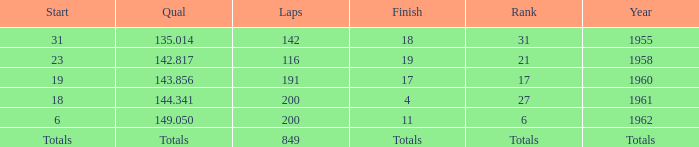What is the year with 116 laps? 1958.0. 